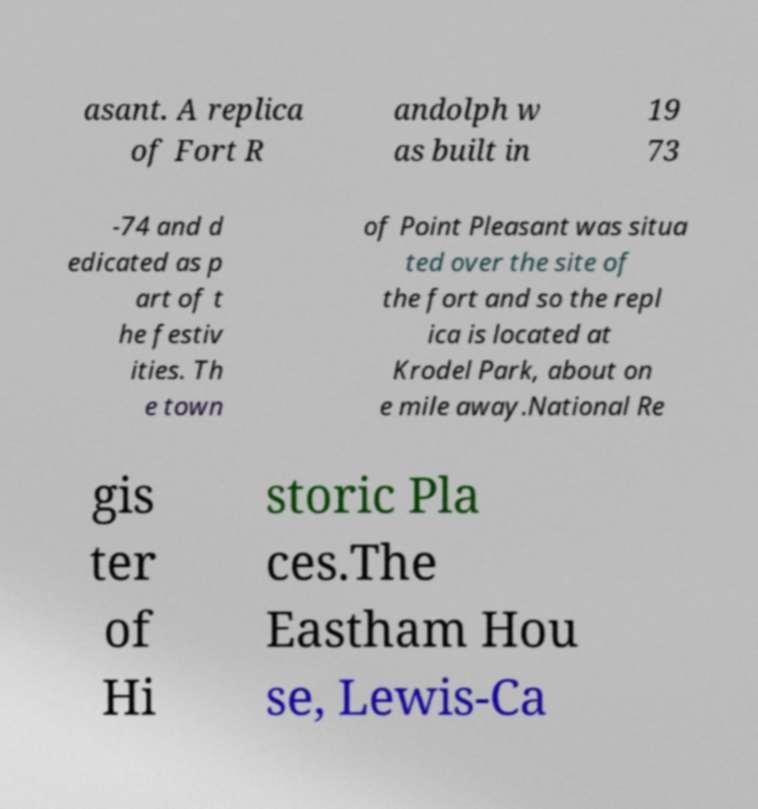Can you accurately transcribe the text from the provided image for me? asant. A replica of Fort R andolph w as built in 19 73 -74 and d edicated as p art of t he festiv ities. Th e town of Point Pleasant was situa ted over the site of the fort and so the repl ica is located at Krodel Park, about on e mile away.National Re gis ter of Hi storic Pla ces.The Eastham Hou se, Lewis-Ca 